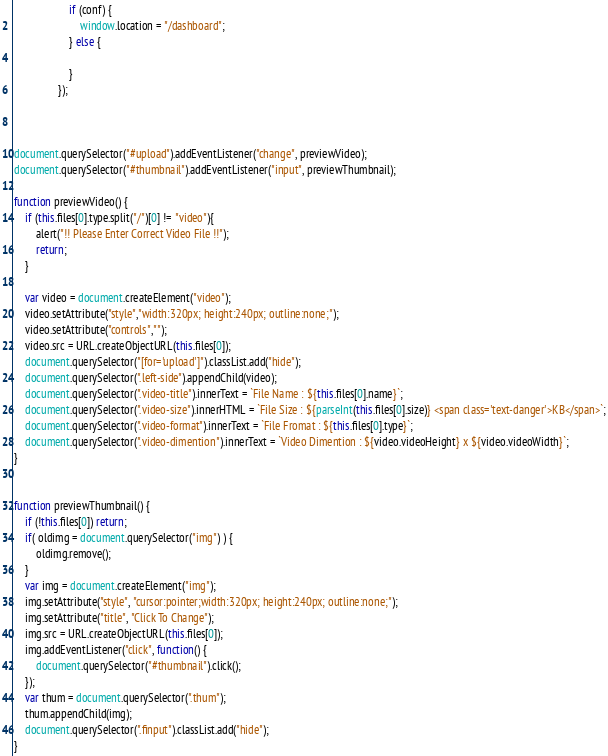Convert code to text. <code><loc_0><loc_0><loc_500><loc_500><_JavaScript_>                    if (conf) {
                        window.location = "/dashboard";
                    } else {

                    }
                });



document.querySelector("#upload").addEventListener("change", previewVideo);
document.querySelector("#thumbnail").addEventListener("input", previewThumbnail);

function previewVideo() {
    if (this.files[0].type.split("/")[0] != "video"){
        alert("!! Please Enter Correct Video File !!");
        return;
    }

    var video = document.createElement("video");
    video.setAttribute("style","width:320px; height:240px; outline:none;");
    video.setAttribute("controls","");
    video.src = URL.createObjectURL(this.files[0]);
    document.querySelector("[for='upload']").classList.add("hide");
    document.querySelector(".left-side").appendChild(video);
    document.querySelector(".video-title").innerText = `File Name : ${this.files[0].name}`;
    document.querySelector(".video-size").innerHTML = `File Size : ${parseInt(this.files[0].size)} <span class='text-danger'>KB</span>`;
    document.querySelector(".video-format").innerText = `File Fromat : ${this.files[0].type}`;
    document.querySelector(".video-dimention").innerText = `Video Dimention : ${video.videoHeight} x ${video.videoWidth}`;
}


function previewThumbnail() {
    if (!this.files[0]) return;
    if( oldimg = document.querySelector("img") ) {
        oldimg.remove();
    }
    var img = document.createElement("img");
    img.setAttribute("style", "cursor:pointer;width:320px; height:240px; outline:none;");
    img.setAttribute("title", "Click To Change");
    img.src = URL.createObjectURL(this.files[0]);
    img.addEventListener("click", function() {
        document.querySelector("#thumbnail").click();
    });
    var thum = document.querySelector(".thum");
    thum.appendChild(img);
    document.querySelector(".finput").classList.add("hide");
}
</code> 